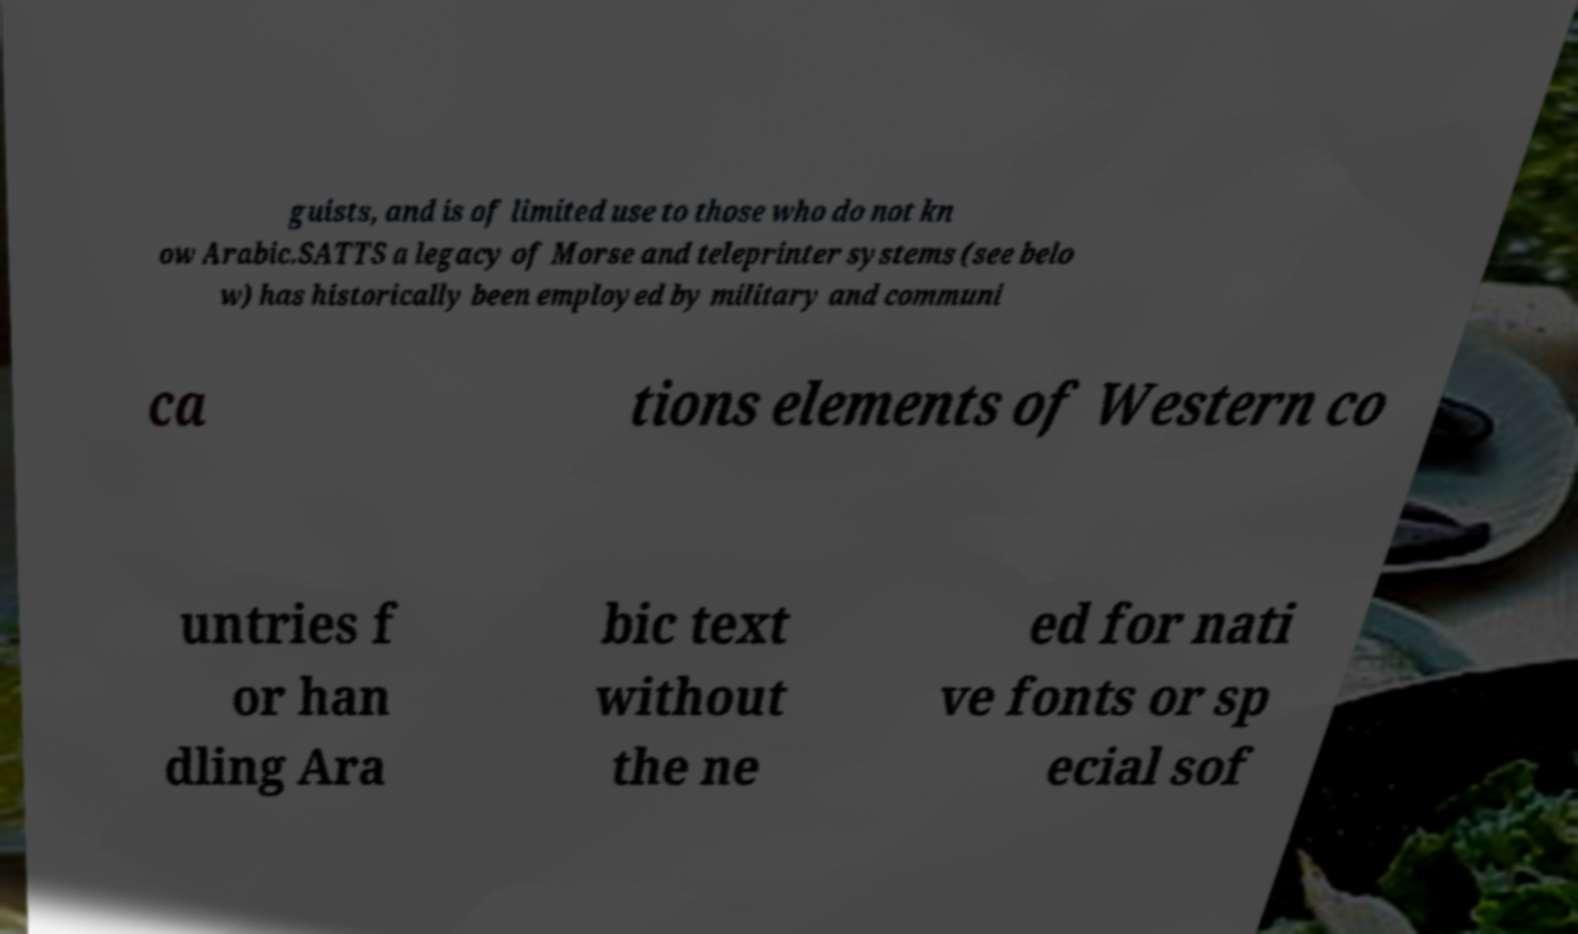Could you extract and type out the text from this image? guists, and is of limited use to those who do not kn ow Arabic.SATTS a legacy of Morse and teleprinter systems (see belo w) has historically been employed by military and communi ca tions elements of Western co untries f or han dling Ara bic text without the ne ed for nati ve fonts or sp ecial sof 